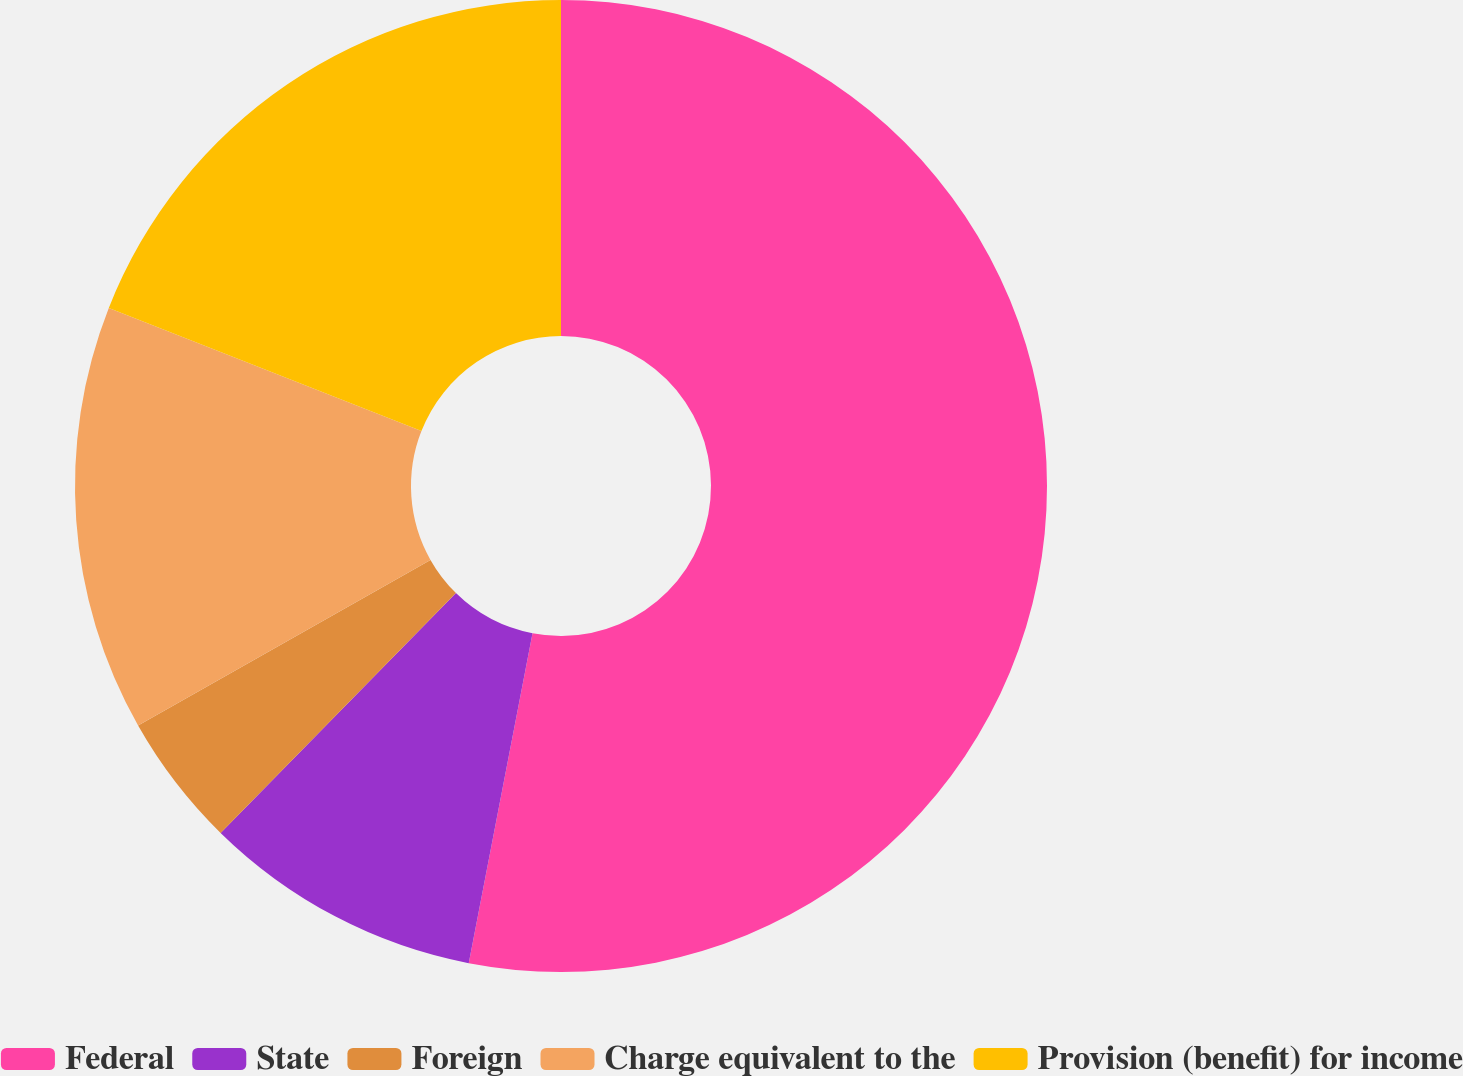Convert chart to OTSL. <chart><loc_0><loc_0><loc_500><loc_500><pie_chart><fcel>Federal<fcel>State<fcel>Foreign<fcel>Charge equivalent to the<fcel>Provision (benefit) for income<nl><fcel>53.04%<fcel>9.31%<fcel>4.45%<fcel>14.17%<fcel>19.03%<nl></chart> 